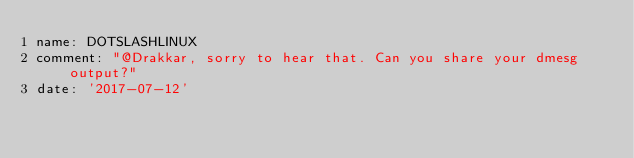<code> <loc_0><loc_0><loc_500><loc_500><_YAML_>name: DOTSLASHLINUX
comment: "@Drakkar, sorry to hear that. Can you share your dmesg output?"
date: '2017-07-12'
</code> 